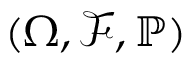Convert formula to latex. <formula><loc_0><loc_0><loc_500><loc_500>( \Omega , \mathcal { F } , \mathbb { P } )</formula> 